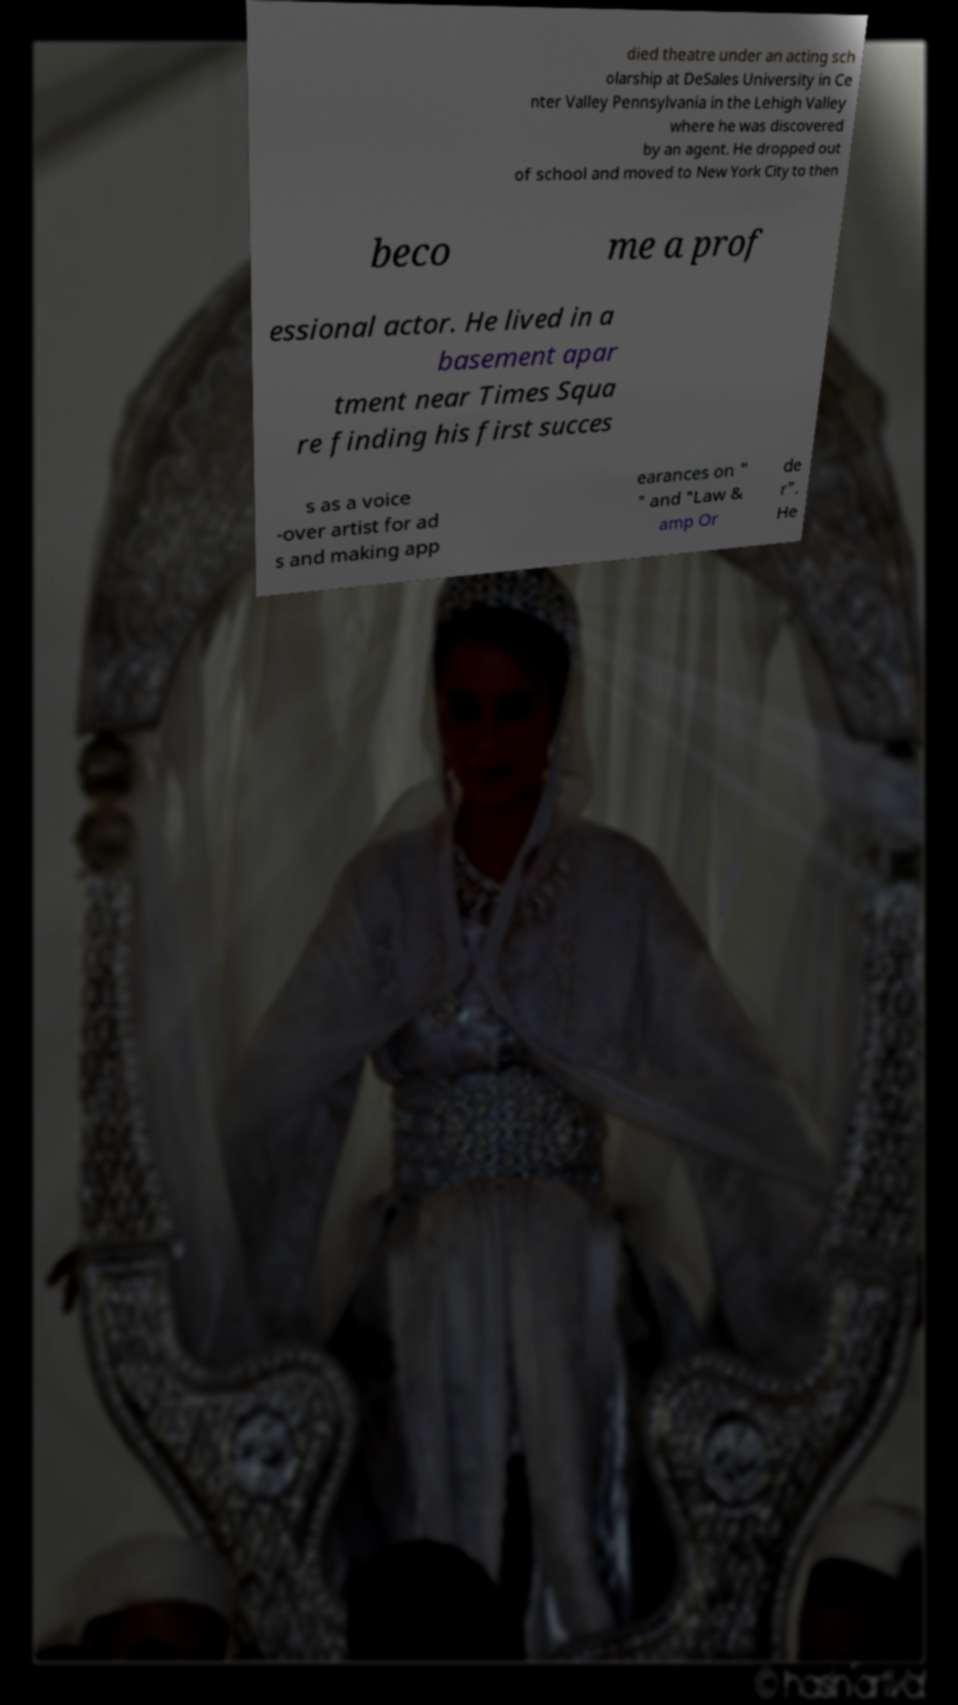Could you extract and type out the text from this image? died theatre under an acting sch olarship at DeSales University in Ce nter Valley Pennsylvania in the Lehigh Valley where he was discovered by an agent. He dropped out of school and moved to New York City to then beco me a prof essional actor. He lived in a basement apar tment near Times Squa re finding his first succes s as a voice -over artist for ad s and making app earances on " " and "Law & amp Or de r". He 